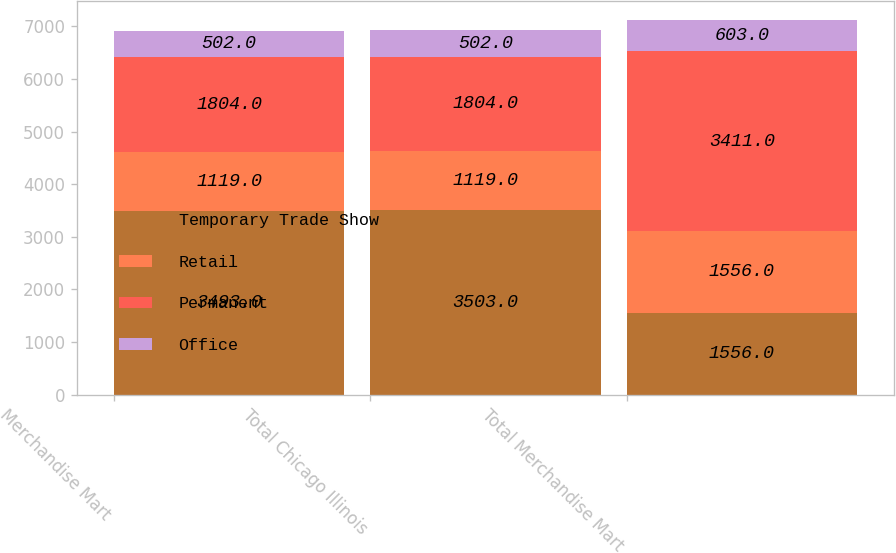Convert chart. <chart><loc_0><loc_0><loc_500><loc_500><stacked_bar_chart><ecel><fcel>Merchandise Mart<fcel>Total Chicago Illinois<fcel>Total Merchandise Mart<nl><fcel>Temporary Trade Show<fcel>3493<fcel>3503<fcel>1556<nl><fcel>Retail<fcel>1119<fcel>1119<fcel>1556<nl><fcel>Permanent<fcel>1804<fcel>1804<fcel>3411<nl><fcel>Office<fcel>502<fcel>502<fcel>603<nl></chart> 